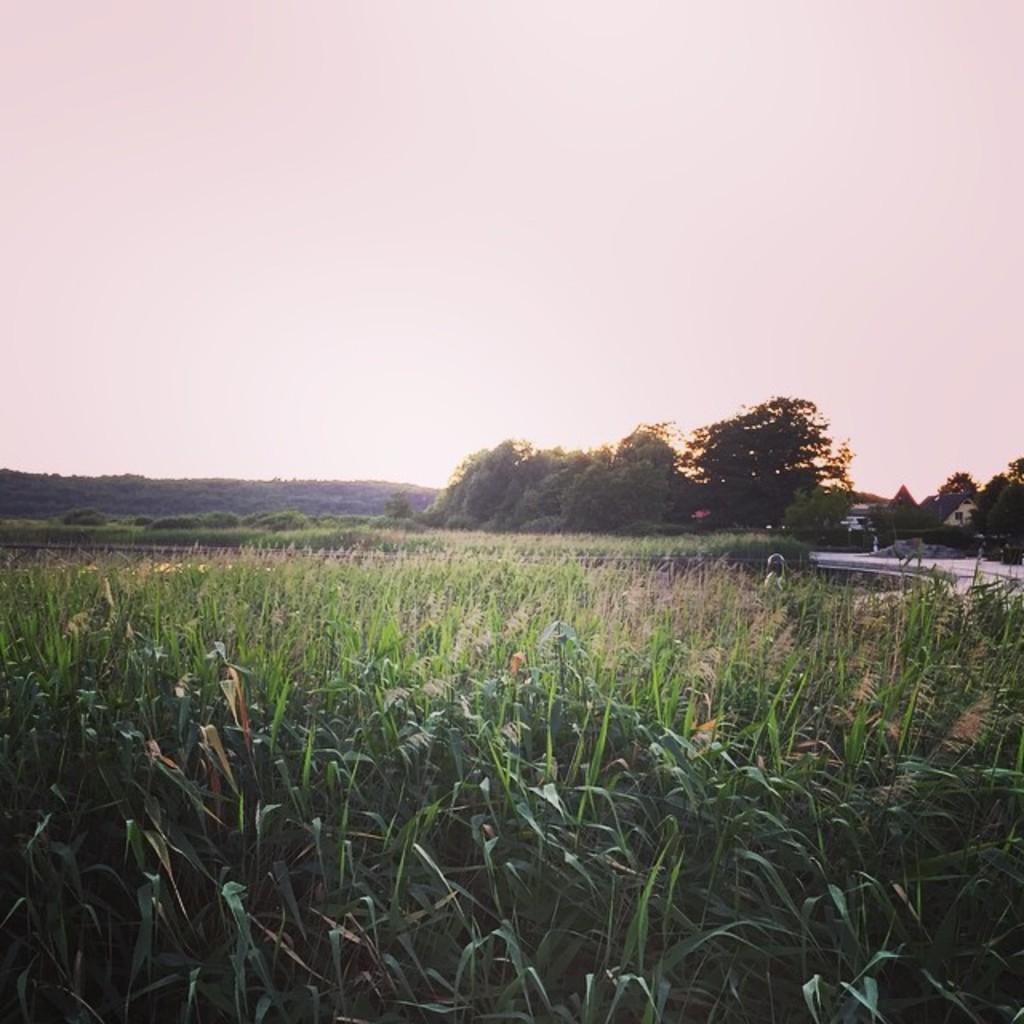Could you give a brief overview of what you see in this image? This is an outside view. At the bottom of the image there are many plants. On the right side there is a road, few houses and trees. At the top of the image I can see the sky. 